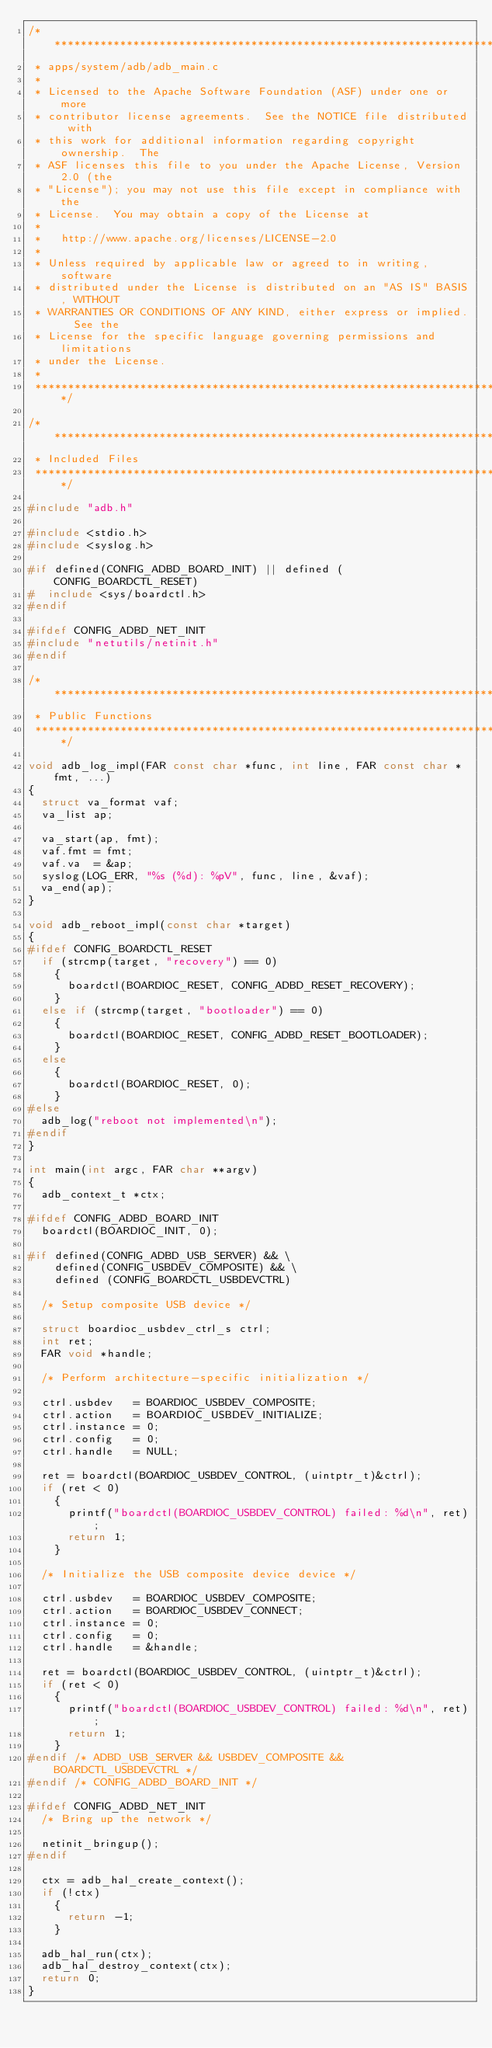Convert code to text. <code><loc_0><loc_0><loc_500><loc_500><_C_>/****************************************************************************
 * apps/system/adb/adb_main.c
 *
 * Licensed to the Apache Software Foundation (ASF) under one or more
 * contributor license agreements.  See the NOTICE file distributed with
 * this work for additional information regarding copyright ownership.  The
 * ASF licenses this file to you under the Apache License, Version 2.0 (the
 * "License"); you may not use this file except in compliance with the
 * License.  You may obtain a copy of the License at
 *
 *   http://www.apache.org/licenses/LICENSE-2.0
 *
 * Unless required by applicable law or agreed to in writing, software
 * distributed under the License is distributed on an "AS IS" BASIS, WITHOUT
 * WARRANTIES OR CONDITIONS OF ANY KIND, either express or implied.  See the
 * License for the specific language governing permissions and limitations
 * under the License.
 *
 ****************************************************************************/

/****************************************************************************
 * Included Files
 ****************************************************************************/

#include "adb.h"

#include <stdio.h>
#include <syslog.h>

#if defined(CONFIG_ADBD_BOARD_INIT) || defined (CONFIG_BOARDCTL_RESET)
#  include <sys/boardctl.h>
#endif

#ifdef CONFIG_ADBD_NET_INIT
#include "netutils/netinit.h"
#endif

/****************************************************************************
 * Public Functions
 ****************************************************************************/

void adb_log_impl(FAR const char *func, int line, FAR const char *fmt, ...)
{
  struct va_format vaf;
  va_list ap;

  va_start(ap, fmt);
  vaf.fmt = fmt;
  vaf.va  = &ap;
  syslog(LOG_ERR, "%s (%d): %pV", func, line, &vaf);
  va_end(ap);
}

void adb_reboot_impl(const char *target)
{
#ifdef CONFIG_BOARDCTL_RESET
  if (strcmp(target, "recovery") == 0)
    {
      boardctl(BOARDIOC_RESET, CONFIG_ADBD_RESET_RECOVERY);
    }
  else if (strcmp(target, "bootloader") == 0)
    {
      boardctl(BOARDIOC_RESET, CONFIG_ADBD_RESET_BOOTLOADER);
    }
  else
    {
      boardctl(BOARDIOC_RESET, 0);
    }
#else
  adb_log("reboot not implemented\n");
#endif
}

int main(int argc, FAR char **argv)
{
  adb_context_t *ctx;

#ifdef CONFIG_ADBD_BOARD_INIT
  boardctl(BOARDIOC_INIT, 0);

#if defined(CONFIG_ADBD_USB_SERVER) && \
    defined(CONFIG_USBDEV_COMPOSITE) && \
    defined (CONFIG_BOARDCTL_USBDEVCTRL)

  /* Setup composite USB device */

  struct boardioc_usbdev_ctrl_s ctrl;
  int ret;
  FAR void *handle;

  /* Perform architecture-specific initialization */

  ctrl.usbdev   = BOARDIOC_USBDEV_COMPOSITE;
  ctrl.action   = BOARDIOC_USBDEV_INITIALIZE;
  ctrl.instance = 0;
  ctrl.config   = 0;
  ctrl.handle   = NULL;

  ret = boardctl(BOARDIOC_USBDEV_CONTROL, (uintptr_t)&ctrl);
  if (ret < 0)
    {
      printf("boardctl(BOARDIOC_USBDEV_CONTROL) failed: %d\n", ret);
      return 1;
    }

  /* Initialize the USB composite device device */

  ctrl.usbdev   = BOARDIOC_USBDEV_COMPOSITE;
  ctrl.action   = BOARDIOC_USBDEV_CONNECT;
  ctrl.instance = 0;
  ctrl.config   = 0;
  ctrl.handle   = &handle;

  ret = boardctl(BOARDIOC_USBDEV_CONTROL, (uintptr_t)&ctrl);
  if (ret < 0)
    {
      printf("boardctl(BOARDIOC_USBDEV_CONTROL) failed: %d\n", ret);
      return 1;
    }
#endif /* ADBD_USB_SERVER && USBDEV_COMPOSITE && BOARDCTL_USBDEVCTRL */
#endif /* CONFIG_ADBD_BOARD_INIT */

#ifdef CONFIG_ADBD_NET_INIT
  /* Bring up the network */

  netinit_bringup();
#endif

  ctx = adb_hal_create_context();
  if (!ctx)
    {
      return -1;
    }

  adb_hal_run(ctx);
  adb_hal_destroy_context(ctx);
  return 0;
}
</code> 